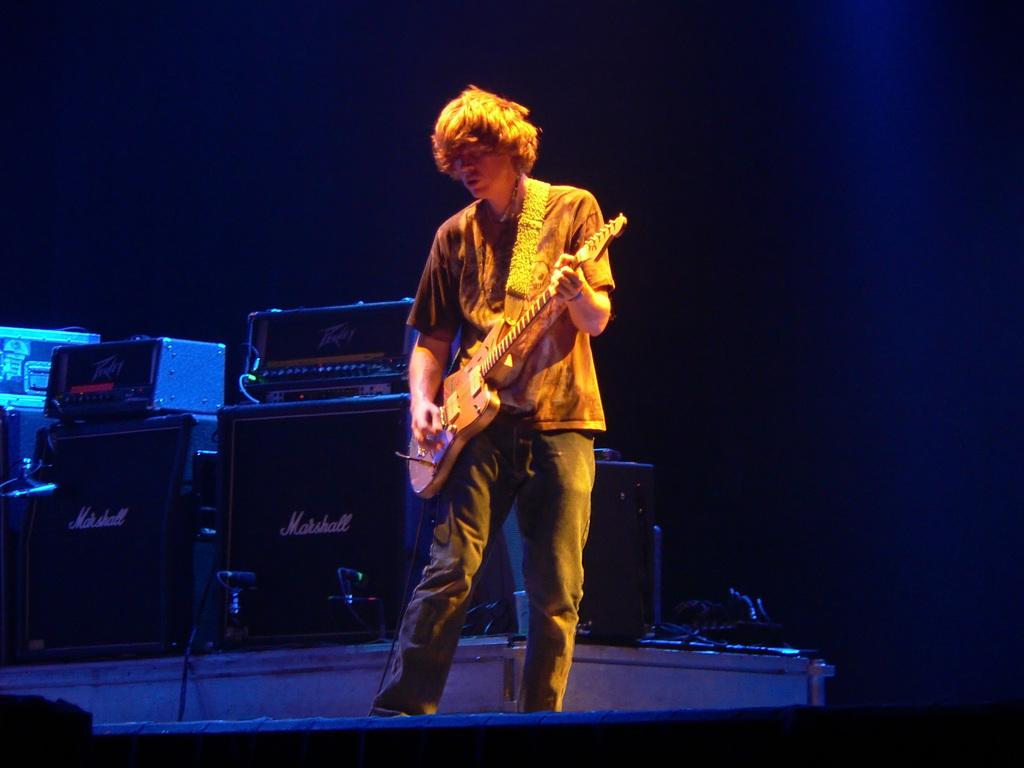What is the main subject of the image? There is a man in the image. What is the man doing in the image? The man is standing in the image. What object is the man holding in his hand? The man is holding a guitar in his hand. What other items can be seen in the image? There are speakers visible in the image. What type of animals can be seen at the zoo in the image? There is no zoo or animals present in the image; it features a man holding a guitar and speakers. What kind of machine is being used to transport the van in the image? There is no van or machine present in the image. 